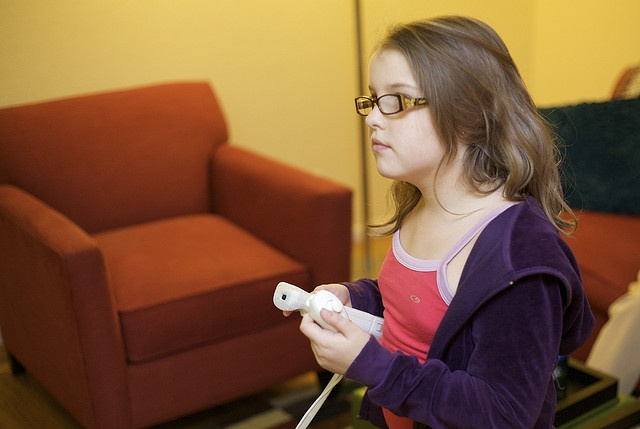Describe the objects in this image and their specific colors. I can see chair in tan, maroon, and brown tones, people in tan, black, gray, and maroon tones, couch in tan, black, maroon, and olive tones, remote in tan, lightgray, darkgray, and black tones, and remote in tan, white, and lightgray tones in this image. 